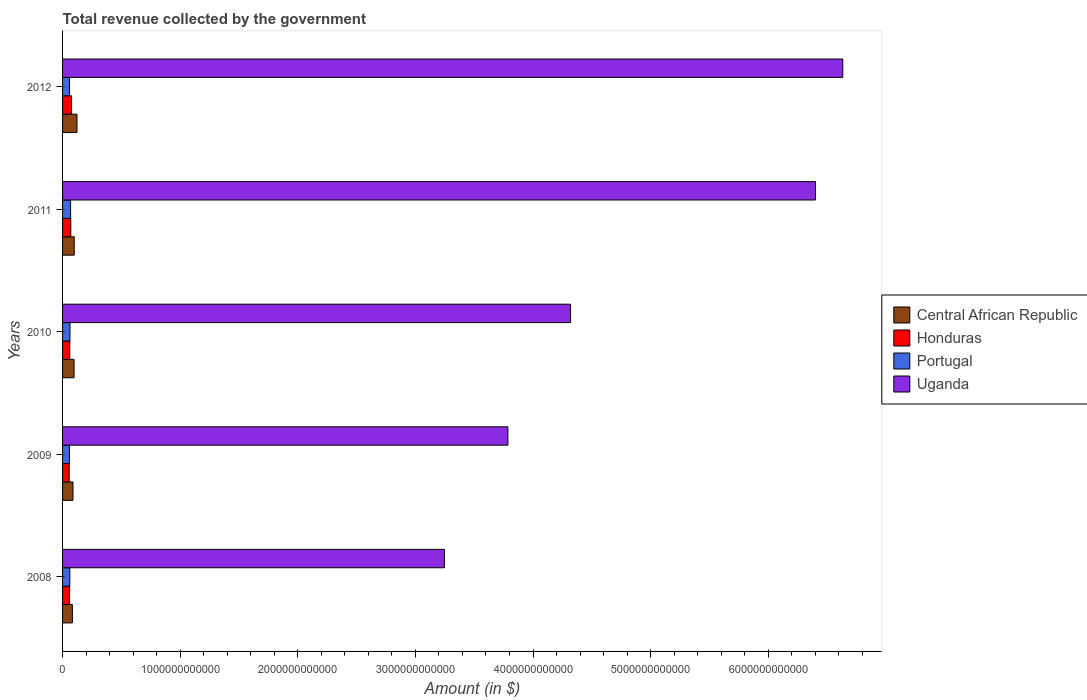How many different coloured bars are there?
Your answer should be compact. 4. How many groups of bars are there?
Ensure brevity in your answer.  5. How many bars are there on the 1st tick from the bottom?
Ensure brevity in your answer.  4. What is the label of the 3rd group of bars from the top?
Offer a very short reply. 2010. In how many cases, is the number of bars for a given year not equal to the number of legend labels?
Give a very brief answer. 0. What is the total revenue collected by the government in Honduras in 2009?
Your answer should be compact. 5.63e+1. Across all years, what is the maximum total revenue collected by the government in Portugal?
Your response must be concise. 6.84e+1. Across all years, what is the minimum total revenue collected by the government in Portugal?
Provide a short and direct response. 5.81e+1. In which year was the total revenue collected by the government in Uganda minimum?
Ensure brevity in your answer.  2008. What is the total total revenue collected by the government in Central African Republic in the graph?
Your response must be concise. 4.91e+11. What is the difference between the total revenue collected by the government in Central African Republic in 2008 and that in 2009?
Give a very brief answer. -5.06e+09. What is the difference between the total revenue collected by the government in Uganda in 2011 and the total revenue collected by the government in Honduras in 2012?
Your response must be concise. 6.33e+12. What is the average total revenue collected by the government in Portugal per year?
Ensure brevity in your answer.  6.20e+1. In the year 2010, what is the difference between the total revenue collected by the government in Portugal and total revenue collected by the government in Honduras?
Make the answer very short. 1.45e+09. What is the ratio of the total revenue collected by the government in Portugal in 2009 to that in 2012?
Give a very brief answer. 0.99. Is the total revenue collected by the government in Uganda in 2009 less than that in 2011?
Make the answer very short. Yes. Is the difference between the total revenue collected by the government in Portugal in 2008 and 2012 greater than the difference between the total revenue collected by the government in Honduras in 2008 and 2012?
Provide a succinct answer. Yes. What is the difference between the highest and the second highest total revenue collected by the government in Uganda?
Your answer should be very brief. 2.32e+11. What is the difference between the highest and the lowest total revenue collected by the government in Uganda?
Your answer should be very brief. 3.39e+12. Is the sum of the total revenue collected by the government in Uganda in 2009 and 2010 greater than the maximum total revenue collected by the government in Honduras across all years?
Provide a short and direct response. Yes. What does the 1st bar from the top in 2009 represents?
Offer a very short reply. Uganda. What does the 1st bar from the bottom in 2009 represents?
Give a very brief answer. Central African Republic. Is it the case that in every year, the sum of the total revenue collected by the government in Honduras and total revenue collected by the government in Portugal is greater than the total revenue collected by the government in Uganda?
Offer a terse response. No. How many bars are there?
Your response must be concise. 20. How many years are there in the graph?
Offer a terse response. 5. What is the difference between two consecutive major ticks on the X-axis?
Your answer should be compact. 1.00e+12. Does the graph contain any zero values?
Offer a terse response. No. Does the graph contain grids?
Your answer should be compact. No. Where does the legend appear in the graph?
Give a very brief answer. Center right. What is the title of the graph?
Offer a very short reply. Total revenue collected by the government. Does "Colombia" appear as one of the legend labels in the graph?
Ensure brevity in your answer.  No. What is the label or title of the X-axis?
Keep it short and to the point. Amount (in $). What is the label or title of the Y-axis?
Your answer should be compact. Years. What is the Amount (in $) of Central African Republic in 2008?
Offer a very short reply. 8.35e+1. What is the Amount (in $) of Honduras in 2008?
Offer a very short reply. 5.97e+1. What is the Amount (in $) of Portugal in 2008?
Your answer should be very brief. 6.20e+1. What is the Amount (in $) in Uganda in 2008?
Provide a succinct answer. 3.25e+12. What is the Amount (in $) of Central African Republic in 2009?
Keep it short and to the point. 8.86e+1. What is the Amount (in $) in Honduras in 2009?
Keep it short and to the point. 5.63e+1. What is the Amount (in $) in Portugal in 2009?
Give a very brief answer. 5.81e+1. What is the Amount (in $) in Uganda in 2009?
Your answer should be compact. 3.79e+12. What is the Amount (in $) of Central African Republic in 2010?
Ensure brevity in your answer.  9.76e+1. What is the Amount (in $) of Honduras in 2010?
Keep it short and to the point. 6.15e+1. What is the Amount (in $) of Portugal in 2010?
Offer a terse response. 6.30e+1. What is the Amount (in $) of Uganda in 2010?
Your answer should be very brief. 4.32e+12. What is the Amount (in $) of Central African Republic in 2011?
Provide a short and direct response. 9.91e+1. What is the Amount (in $) of Honduras in 2011?
Keep it short and to the point. 7.00e+1. What is the Amount (in $) of Portugal in 2011?
Ensure brevity in your answer.  6.84e+1. What is the Amount (in $) in Uganda in 2011?
Make the answer very short. 6.40e+12. What is the Amount (in $) in Central African Republic in 2012?
Offer a very short reply. 1.22e+11. What is the Amount (in $) in Honduras in 2012?
Provide a short and direct response. 7.66e+1. What is the Amount (in $) in Portugal in 2012?
Offer a terse response. 5.88e+1. What is the Amount (in $) in Uganda in 2012?
Offer a terse response. 6.63e+12. Across all years, what is the maximum Amount (in $) in Central African Republic?
Keep it short and to the point. 1.22e+11. Across all years, what is the maximum Amount (in $) in Honduras?
Your answer should be very brief. 7.66e+1. Across all years, what is the maximum Amount (in $) in Portugal?
Keep it short and to the point. 6.84e+1. Across all years, what is the maximum Amount (in $) of Uganda?
Your response must be concise. 6.63e+12. Across all years, what is the minimum Amount (in $) of Central African Republic?
Your response must be concise. 8.35e+1. Across all years, what is the minimum Amount (in $) in Honduras?
Ensure brevity in your answer.  5.63e+1. Across all years, what is the minimum Amount (in $) of Portugal?
Provide a succinct answer. 5.81e+1. Across all years, what is the minimum Amount (in $) of Uganda?
Keep it short and to the point. 3.25e+12. What is the total Amount (in $) of Central African Republic in the graph?
Give a very brief answer. 4.91e+11. What is the total Amount (in $) in Honduras in the graph?
Provide a short and direct response. 3.24e+11. What is the total Amount (in $) of Portugal in the graph?
Offer a terse response. 3.10e+11. What is the total Amount (in $) in Uganda in the graph?
Give a very brief answer. 2.44e+13. What is the difference between the Amount (in $) of Central African Republic in 2008 and that in 2009?
Provide a succinct answer. -5.06e+09. What is the difference between the Amount (in $) of Honduras in 2008 and that in 2009?
Offer a terse response. 3.40e+09. What is the difference between the Amount (in $) of Portugal in 2008 and that in 2009?
Offer a very short reply. 3.93e+09. What is the difference between the Amount (in $) of Uganda in 2008 and that in 2009?
Make the answer very short. -5.40e+11. What is the difference between the Amount (in $) of Central African Republic in 2008 and that in 2010?
Provide a short and direct response. -1.41e+1. What is the difference between the Amount (in $) of Honduras in 2008 and that in 2010?
Your answer should be very brief. -1.84e+09. What is the difference between the Amount (in $) in Portugal in 2008 and that in 2010?
Make the answer very short. -9.80e+08. What is the difference between the Amount (in $) in Uganda in 2008 and that in 2010?
Your response must be concise. -1.07e+12. What is the difference between the Amount (in $) in Central African Republic in 2008 and that in 2011?
Ensure brevity in your answer.  -1.56e+1. What is the difference between the Amount (in $) in Honduras in 2008 and that in 2011?
Ensure brevity in your answer.  -1.03e+1. What is the difference between the Amount (in $) in Portugal in 2008 and that in 2011?
Provide a succinct answer. -6.42e+09. What is the difference between the Amount (in $) in Uganda in 2008 and that in 2011?
Your answer should be compact. -3.16e+12. What is the difference between the Amount (in $) of Central African Republic in 2008 and that in 2012?
Provide a succinct answer. -3.89e+1. What is the difference between the Amount (in $) in Honduras in 2008 and that in 2012?
Give a very brief answer. -1.69e+1. What is the difference between the Amount (in $) of Portugal in 2008 and that in 2012?
Provide a short and direct response. 3.23e+09. What is the difference between the Amount (in $) of Uganda in 2008 and that in 2012?
Ensure brevity in your answer.  -3.39e+12. What is the difference between the Amount (in $) of Central African Republic in 2009 and that in 2010?
Provide a succinct answer. -9.03e+09. What is the difference between the Amount (in $) in Honduras in 2009 and that in 2010?
Give a very brief answer. -5.23e+09. What is the difference between the Amount (in $) in Portugal in 2009 and that in 2010?
Provide a succinct answer. -4.91e+09. What is the difference between the Amount (in $) of Uganda in 2009 and that in 2010?
Ensure brevity in your answer.  -5.33e+11. What is the difference between the Amount (in $) in Central African Republic in 2009 and that in 2011?
Your response must be concise. -1.05e+1. What is the difference between the Amount (in $) of Honduras in 2009 and that in 2011?
Your answer should be very brief. -1.37e+1. What is the difference between the Amount (in $) in Portugal in 2009 and that in 2011?
Provide a short and direct response. -1.04e+1. What is the difference between the Amount (in $) of Uganda in 2009 and that in 2011?
Your answer should be very brief. -2.62e+12. What is the difference between the Amount (in $) in Central African Republic in 2009 and that in 2012?
Provide a short and direct response. -3.39e+1. What is the difference between the Amount (in $) of Honduras in 2009 and that in 2012?
Give a very brief answer. -2.03e+1. What is the difference between the Amount (in $) of Portugal in 2009 and that in 2012?
Make the answer very short. -7.04e+08. What is the difference between the Amount (in $) in Uganda in 2009 and that in 2012?
Provide a short and direct response. -2.85e+12. What is the difference between the Amount (in $) in Central African Republic in 2010 and that in 2011?
Your answer should be compact. -1.48e+09. What is the difference between the Amount (in $) of Honduras in 2010 and that in 2011?
Keep it short and to the point. -8.49e+09. What is the difference between the Amount (in $) of Portugal in 2010 and that in 2011?
Provide a short and direct response. -5.44e+09. What is the difference between the Amount (in $) of Uganda in 2010 and that in 2011?
Offer a very short reply. -2.08e+12. What is the difference between the Amount (in $) of Central African Republic in 2010 and that in 2012?
Offer a very short reply. -2.48e+1. What is the difference between the Amount (in $) of Honduras in 2010 and that in 2012?
Offer a very short reply. -1.50e+1. What is the difference between the Amount (in $) of Portugal in 2010 and that in 2012?
Your response must be concise. 4.21e+09. What is the difference between the Amount (in $) in Uganda in 2010 and that in 2012?
Your answer should be compact. -2.31e+12. What is the difference between the Amount (in $) in Central African Republic in 2011 and that in 2012?
Your answer should be compact. -2.33e+1. What is the difference between the Amount (in $) of Honduras in 2011 and that in 2012?
Give a very brief answer. -6.55e+09. What is the difference between the Amount (in $) in Portugal in 2011 and that in 2012?
Make the answer very short. 9.65e+09. What is the difference between the Amount (in $) of Uganda in 2011 and that in 2012?
Keep it short and to the point. -2.32e+11. What is the difference between the Amount (in $) in Central African Republic in 2008 and the Amount (in $) in Honduras in 2009?
Give a very brief answer. 2.72e+1. What is the difference between the Amount (in $) of Central African Republic in 2008 and the Amount (in $) of Portugal in 2009?
Make the answer very short. 2.55e+1. What is the difference between the Amount (in $) of Central African Republic in 2008 and the Amount (in $) of Uganda in 2009?
Ensure brevity in your answer.  -3.70e+12. What is the difference between the Amount (in $) in Honduras in 2008 and the Amount (in $) in Portugal in 2009?
Give a very brief answer. 1.63e+09. What is the difference between the Amount (in $) in Honduras in 2008 and the Amount (in $) in Uganda in 2009?
Make the answer very short. -3.73e+12. What is the difference between the Amount (in $) in Portugal in 2008 and the Amount (in $) in Uganda in 2009?
Provide a succinct answer. -3.72e+12. What is the difference between the Amount (in $) of Central African Republic in 2008 and the Amount (in $) of Honduras in 2010?
Offer a terse response. 2.20e+1. What is the difference between the Amount (in $) in Central African Republic in 2008 and the Amount (in $) in Portugal in 2010?
Make the answer very short. 2.05e+1. What is the difference between the Amount (in $) in Central African Republic in 2008 and the Amount (in $) in Uganda in 2010?
Keep it short and to the point. -4.24e+12. What is the difference between the Amount (in $) of Honduras in 2008 and the Amount (in $) of Portugal in 2010?
Your answer should be very brief. -3.29e+09. What is the difference between the Amount (in $) of Honduras in 2008 and the Amount (in $) of Uganda in 2010?
Ensure brevity in your answer.  -4.26e+12. What is the difference between the Amount (in $) in Portugal in 2008 and the Amount (in $) in Uganda in 2010?
Ensure brevity in your answer.  -4.26e+12. What is the difference between the Amount (in $) in Central African Republic in 2008 and the Amount (in $) in Honduras in 2011?
Ensure brevity in your answer.  1.35e+1. What is the difference between the Amount (in $) of Central African Republic in 2008 and the Amount (in $) of Portugal in 2011?
Your answer should be very brief. 1.51e+1. What is the difference between the Amount (in $) in Central African Republic in 2008 and the Amount (in $) in Uganda in 2011?
Offer a terse response. -6.32e+12. What is the difference between the Amount (in $) in Honduras in 2008 and the Amount (in $) in Portugal in 2011?
Your answer should be compact. -8.73e+09. What is the difference between the Amount (in $) of Honduras in 2008 and the Amount (in $) of Uganda in 2011?
Give a very brief answer. -6.34e+12. What is the difference between the Amount (in $) in Portugal in 2008 and the Amount (in $) in Uganda in 2011?
Give a very brief answer. -6.34e+12. What is the difference between the Amount (in $) of Central African Republic in 2008 and the Amount (in $) of Honduras in 2012?
Keep it short and to the point. 6.96e+09. What is the difference between the Amount (in $) in Central African Republic in 2008 and the Amount (in $) in Portugal in 2012?
Give a very brief answer. 2.48e+1. What is the difference between the Amount (in $) in Central African Republic in 2008 and the Amount (in $) in Uganda in 2012?
Give a very brief answer. -6.55e+12. What is the difference between the Amount (in $) of Honduras in 2008 and the Amount (in $) of Portugal in 2012?
Provide a short and direct response. 9.21e+08. What is the difference between the Amount (in $) of Honduras in 2008 and the Amount (in $) of Uganda in 2012?
Offer a terse response. -6.57e+12. What is the difference between the Amount (in $) of Portugal in 2008 and the Amount (in $) of Uganda in 2012?
Your response must be concise. -6.57e+12. What is the difference between the Amount (in $) in Central African Republic in 2009 and the Amount (in $) in Honduras in 2010?
Offer a very short reply. 2.71e+1. What is the difference between the Amount (in $) in Central African Republic in 2009 and the Amount (in $) in Portugal in 2010?
Provide a succinct answer. 2.56e+1. What is the difference between the Amount (in $) of Central African Republic in 2009 and the Amount (in $) of Uganda in 2010?
Provide a succinct answer. -4.23e+12. What is the difference between the Amount (in $) of Honduras in 2009 and the Amount (in $) of Portugal in 2010?
Your response must be concise. -6.69e+09. What is the difference between the Amount (in $) in Honduras in 2009 and the Amount (in $) in Uganda in 2010?
Make the answer very short. -4.26e+12. What is the difference between the Amount (in $) of Portugal in 2009 and the Amount (in $) of Uganda in 2010?
Offer a terse response. -4.26e+12. What is the difference between the Amount (in $) of Central African Republic in 2009 and the Amount (in $) of Honduras in 2011?
Ensure brevity in your answer.  1.86e+1. What is the difference between the Amount (in $) in Central African Republic in 2009 and the Amount (in $) in Portugal in 2011?
Your answer should be very brief. 2.02e+1. What is the difference between the Amount (in $) of Central African Republic in 2009 and the Amount (in $) of Uganda in 2011?
Ensure brevity in your answer.  -6.31e+12. What is the difference between the Amount (in $) in Honduras in 2009 and the Amount (in $) in Portugal in 2011?
Your answer should be compact. -1.21e+1. What is the difference between the Amount (in $) of Honduras in 2009 and the Amount (in $) of Uganda in 2011?
Offer a terse response. -6.35e+12. What is the difference between the Amount (in $) of Portugal in 2009 and the Amount (in $) of Uganda in 2011?
Make the answer very short. -6.34e+12. What is the difference between the Amount (in $) in Central African Republic in 2009 and the Amount (in $) in Honduras in 2012?
Your answer should be very brief. 1.20e+1. What is the difference between the Amount (in $) in Central African Republic in 2009 and the Amount (in $) in Portugal in 2012?
Offer a terse response. 2.98e+1. What is the difference between the Amount (in $) in Central African Republic in 2009 and the Amount (in $) in Uganda in 2012?
Keep it short and to the point. -6.55e+12. What is the difference between the Amount (in $) of Honduras in 2009 and the Amount (in $) of Portugal in 2012?
Keep it short and to the point. -2.48e+09. What is the difference between the Amount (in $) of Honduras in 2009 and the Amount (in $) of Uganda in 2012?
Keep it short and to the point. -6.58e+12. What is the difference between the Amount (in $) in Portugal in 2009 and the Amount (in $) in Uganda in 2012?
Your response must be concise. -6.58e+12. What is the difference between the Amount (in $) in Central African Republic in 2010 and the Amount (in $) in Honduras in 2011?
Make the answer very short. 2.76e+1. What is the difference between the Amount (in $) of Central African Republic in 2010 and the Amount (in $) of Portugal in 2011?
Your answer should be very brief. 2.92e+1. What is the difference between the Amount (in $) of Central African Republic in 2010 and the Amount (in $) of Uganda in 2011?
Your answer should be compact. -6.30e+12. What is the difference between the Amount (in $) in Honduras in 2010 and the Amount (in $) in Portugal in 2011?
Offer a terse response. -6.89e+09. What is the difference between the Amount (in $) of Honduras in 2010 and the Amount (in $) of Uganda in 2011?
Keep it short and to the point. -6.34e+12. What is the difference between the Amount (in $) in Portugal in 2010 and the Amount (in $) in Uganda in 2011?
Your answer should be compact. -6.34e+12. What is the difference between the Amount (in $) in Central African Republic in 2010 and the Amount (in $) in Honduras in 2012?
Provide a short and direct response. 2.11e+1. What is the difference between the Amount (in $) of Central African Republic in 2010 and the Amount (in $) of Portugal in 2012?
Provide a short and direct response. 3.89e+1. What is the difference between the Amount (in $) of Central African Republic in 2010 and the Amount (in $) of Uganda in 2012?
Give a very brief answer. -6.54e+12. What is the difference between the Amount (in $) of Honduras in 2010 and the Amount (in $) of Portugal in 2012?
Give a very brief answer. 2.76e+09. What is the difference between the Amount (in $) in Honduras in 2010 and the Amount (in $) in Uganda in 2012?
Give a very brief answer. -6.57e+12. What is the difference between the Amount (in $) of Portugal in 2010 and the Amount (in $) of Uganda in 2012?
Provide a short and direct response. -6.57e+12. What is the difference between the Amount (in $) of Central African Republic in 2011 and the Amount (in $) of Honduras in 2012?
Keep it short and to the point. 2.25e+1. What is the difference between the Amount (in $) of Central African Republic in 2011 and the Amount (in $) of Portugal in 2012?
Ensure brevity in your answer.  4.03e+1. What is the difference between the Amount (in $) in Central African Republic in 2011 and the Amount (in $) in Uganda in 2012?
Ensure brevity in your answer.  -6.54e+12. What is the difference between the Amount (in $) in Honduras in 2011 and the Amount (in $) in Portugal in 2012?
Make the answer very short. 1.12e+1. What is the difference between the Amount (in $) of Honduras in 2011 and the Amount (in $) of Uganda in 2012?
Ensure brevity in your answer.  -6.56e+12. What is the difference between the Amount (in $) in Portugal in 2011 and the Amount (in $) in Uganda in 2012?
Make the answer very short. -6.57e+12. What is the average Amount (in $) in Central African Republic per year?
Offer a very short reply. 9.82e+1. What is the average Amount (in $) of Honduras per year?
Your response must be concise. 6.48e+1. What is the average Amount (in $) in Portugal per year?
Your answer should be very brief. 6.20e+1. What is the average Amount (in $) in Uganda per year?
Your answer should be compact. 4.88e+12. In the year 2008, what is the difference between the Amount (in $) in Central African Republic and Amount (in $) in Honduras?
Give a very brief answer. 2.38e+1. In the year 2008, what is the difference between the Amount (in $) of Central African Republic and Amount (in $) of Portugal?
Make the answer very short. 2.15e+1. In the year 2008, what is the difference between the Amount (in $) of Central African Republic and Amount (in $) of Uganda?
Ensure brevity in your answer.  -3.16e+12. In the year 2008, what is the difference between the Amount (in $) in Honduras and Amount (in $) in Portugal?
Ensure brevity in your answer.  -2.31e+09. In the year 2008, what is the difference between the Amount (in $) of Honduras and Amount (in $) of Uganda?
Make the answer very short. -3.19e+12. In the year 2008, what is the difference between the Amount (in $) of Portugal and Amount (in $) of Uganda?
Offer a terse response. -3.18e+12. In the year 2009, what is the difference between the Amount (in $) in Central African Republic and Amount (in $) in Honduras?
Your answer should be compact. 3.23e+1. In the year 2009, what is the difference between the Amount (in $) in Central African Republic and Amount (in $) in Portugal?
Ensure brevity in your answer.  3.05e+1. In the year 2009, what is the difference between the Amount (in $) of Central African Republic and Amount (in $) of Uganda?
Offer a terse response. -3.70e+12. In the year 2009, what is the difference between the Amount (in $) of Honduras and Amount (in $) of Portugal?
Make the answer very short. -1.77e+09. In the year 2009, what is the difference between the Amount (in $) of Honduras and Amount (in $) of Uganda?
Give a very brief answer. -3.73e+12. In the year 2009, what is the difference between the Amount (in $) of Portugal and Amount (in $) of Uganda?
Ensure brevity in your answer.  -3.73e+12. In the year 2010, what is the difference between the Amount (in $) of Central African Republic and Amount (in $) of Honduras?
Give a very brief answer. 3.61e+1. In the year 2010, what is the difference between the Amount (in $) of Central African Republic and Amount (in $) of Portugal?
Provide a succinct answer. 3.46e+1. In the year 2010, what is the difference between the Amount (in $) in Central African Republic and Amount (in $) in Uganda?
Make the answer very short. -4.22e+12. In the year 2010, what is the difference between the Amount (in $) of Honduras and Amount (in $) of Portugal?
Provide a succinct answer. -1.45e+09. In the year 2010, what is the difference between the Amount (in $) in Honduras and Amount (in $) in Uganda?
Keep it short and to the point. -4.26e+12. In the year 2010, what is the difference between the Amount (in $) of Portugal and Amount (in $) of Uganda?
Your response must be concise. -4.26e+12. In the year 2011, what is the difference between the Amount (in $) of Central African Republic and Amount (in $) of Honduras?
Offer a terse response. 2.91e+1. In the year 2011, what is the difference between the Amount (in $) in Central African Republic and Amount (in $) in Portugal?
Provide a succinct answer. 3.07e+1. In the year 2011, what is the difference between the Amount (in $) of Central African Republic and Amount (in $) of Uganda?
Your answer should be very brief. -6.30e+12. In the year 2011, what is the difference between the Amount (in $) of Honduras and Amount (in $) of Portugal?
Give a very brief answer. 1.59e+09. In the year 2011, what is the difference between the Amount (in $) of Honduras and Amount (in $) of Uganda?
Provide a short and direct response. -6.33e+12. In the year 2011, what is the difference between the Amount (in $) of Portugal and Amount (in $) of Uganda?
Make the answer very short. -6.33e+12. In the year 2012, what is the difference between the Amount (in $) of Central African Republic and Amount (in $) of Honduras?
Provide a short and direct response. 4.59e+1. In the year 2012, what is the difference between the Amount (in $) in Central African Republic and Amount (in $) in Portugal?
Provide a short and direct response. 6.37e+1. In the year 2012, what is the difference between the Amount (in $) of Central African Republic and Amount (in $) of Uganda?
Offer a very short reply. -6.51e+12. In the year 2012, what is the difference between the Amount (in $) in Honduras and Amount (in $) in Portugal?
Give a very brief answer. 1.78e+1. In the year 2012, what is the difference between the Amount (in $) in Honduras and Amount (in $) in Uganda?
Your answer should be compact. -6.56e+12. In the year 2012, what is the difference between the Amount (in $) of Portugal and Amount (in $) of Uganda?
Your answer should be compact. -6.58e+12. What is the ratio of the Amount (in $) of Central African Republic in 2008 to that in 2009?
Provide a succinct answer. 0.94. What is the ratio of the Amount (in $) of Honduras in 2008 to that in 2009?
Offer a terse response. 1.06. What is the ratio of the Amount (in $) in Portugal in 2008 to that in 2009?
Keep it short and to the point. 1.07. What is the ratio of the Amount (in $) of Uganda in 2008 to that in 2009?
Offer a terse response. 0.86. What is the ratio of the Amount (in $) in Central African Republic in 2008 to that in 2010?
Your answer should be very brief. 0.86. What is the ratio of the Amount (in $) of Honduras in 2008 to that in 2010?
Give a very brief answer. 0.97. What is the ratio of the Amount (in $) of Portugal in 2008 to that in 2010?
Keep it short and to the point. 0.98. What is the ratio of the Amount (in $) of Uganda in 2008 to that in 2010?
Provide a succinct answer. 0.75. What is the ratio of the Amount (in $) in Central African Republic in 2008 to that in 2011?
Offer a terse response. 0.84. What is the ratio of the Amount (in $) of Honduras in 2008 to that in 2011?
Provide a short and direct response. 0.85. What is the ratio of the Amount (in $) of Portugal in 2008 to that in 2011?
Your response must be concise. 0.91. What is the ratio of the Amount (in $) in Uganda in 2008 to that in 2011?
Provide a short and direct response. 0.51. What is the ratio of the Amount (in $) in Central African Republic in 2008 to that in 2012?
Make the answer very short. 0.68. What is the ratio of the Amount (in $) of Honduras in 2008 to that in 2012?
Offer a very short reply. 0.78. What is the ratio of the Amount (in $) in Portugal in 2008 to that in 2012?
Your answer should be very brief. 1.05. What is the ratio of the Amount (in $) in Uganda in 2008 to that in 2012?
Make the answer very short. 0.49. What is the ratio of the Amount (in $) of Central African Republic in 2009 to that in 2010?
Offer a very short reply. 0.91. What is the ratio of the Amount (in $) in Honduras in 2009 to that in 2010?
Your response must be concise. 0.91. What is the ratio of the Amount (in $) of Portugal in 2009 to that in 2010?
Your answer should be compact. 0.92. What is the ratio of the Amount (in $) of Uganda in 2009 to that in 2010?
Offer a terse response. 0.88. What is the ratio of the Amount (in $) in Central African Republic in 2009 to that in 2011?
Your answer should be very brief. 0.89. What is the ratio of the Amount (in $) in Honduras in 2009 to that in 2011?
Give a very brief answer. 0.8. What is the ratio of the Amount (in $) of Portugal in 2009 to that in 2011?
Offer a terse response. 0.85. What is the ratio of the Amount (in $) of Uganda in 2009 to that in 2011?
Your answer should be very brief. 0.59. What is the ratio of the Amount (in $) in Central African Republic in 2009 to that in 2012?
Your answer should be compact. 0.72. What is the ratio of the Amount (in $) in Honduras in 2009 to that in 2012?
Offer a terse response. 0.74. What is the ratio of the Amount (in $) in Uganda in 2009 to that in 2012?
Provide a succinct answer. 0.57. What is the ratio of the Amount (in $) of Central African Republic in 2010 to that in 2011?
Provide a succinct answer. 0.98. What is the ratio of the Amount (in $) in Honduras in 2010 to that in 2011?
Ensure brevity in your answer.  0.88. What is the ratio of the Amount (in $) of Portugal in 2010 to that in 2011?
Offer a very short reply. 0.92. What is the ratio of the Amount (in $) of Uganda in 2010 to that in 2011?
Your response must be concise. 0.67. What is the ratio of the Amount (in $) in Central African Republic in 2010 to that in 2012?
Your response must be concise. 0.8. What is the ratio of the Amount (in $) in Honduras in 2010 to that in 2012?
Your response must be concise. 0.8. What is the ratio of the Amount (in $) of Portugal in 2010 to that in 2012?
Your answer should be compact. 1.07. What is the ratio of the Amount (in $) of Uganda in 2010 to that in 2012?
Your answer should be very brief. 0.65. What is the ratio of the Amount (in $) of Central African Republic in 2011 to that in 2012?
Keep it short and to the point. 0.81. What is the ratio of the Amount (in $) in Honduras in 2011 to that in 2012?
Offer a terse response. 0.91. What is the ratio of the Amount (in $) of Portugal in 2011 to that in 2012?
Give a very brief answer. 1.16. What is the ratio of the Amount (in $) in Uganda in 2011 to that in 2012?
Ensure brevity in your answer.  0.96. What is the difference between the highest and the second highest Amount (in $) in Central African Republic?
Ensure brevity in your answer.  2.33e+1. What is the difference between the highest and the second highest Amount (in $) in Honduras?
Offer a very short reply. 6.55e+09. What is the difference between the highest and the second highest Amount (in $) in Portugal?
Make the answer very short. 5.44e+09. What is the difference between the highest and the second highest Amount (in $) in Uganda?
Your answer should be compact. 2.32e+11. What is the difference between the highest and the lowest Amount (in $) in Central African Republic?
Offer a very short reply. 3.89e+1. What is the difference between the highest and the lowest Amount (in $) in Honduras?
Your response must be concise. 2.03e+1. What is the difference between the highest and the lowest Amount (in $) in Portugal?
Your answer should be very brief. 1.04e+1. What is the difference between the highest and the lowest Amount (in $) in Uganda?
Offer a terse response. 3.39e+12. 